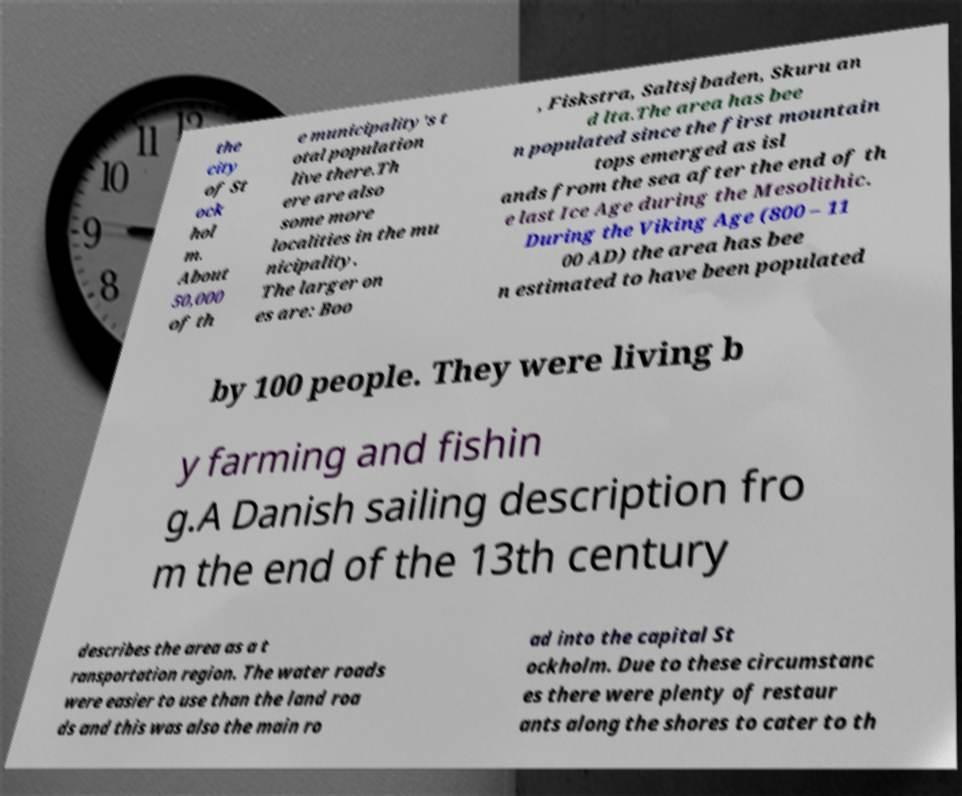Can you read and provide the text displayed in the image?This photo seems to have some interesting text. Can you extract and type it out for me? the city of St ock hol m. About 50,000 of th e municipality's t otal population live there.Th ere are also some more localities in the mu nicipality. The larger on es are: Boo , Fiskstra, Saltsjbaden, Skuru an d lta.The area has bee n populated since the first mountain tops emerged as isl ands from the sea after the end of th e last Ice Age during the Mesolithic. During the Viking Age (800 – 11 00 AD) the area has bee n estimated to have been populated by 100 people. They were living b y farming and fishin g.A Danish sailing description fro m the end of the 13th century describes the area as a t ransportation region. The water roads were easier to use than the land roa ds and this was also the main ro ad into the capital St ockholm. Due to these circumstanc es there were plenty of restaur ants along the shores to cater to th 